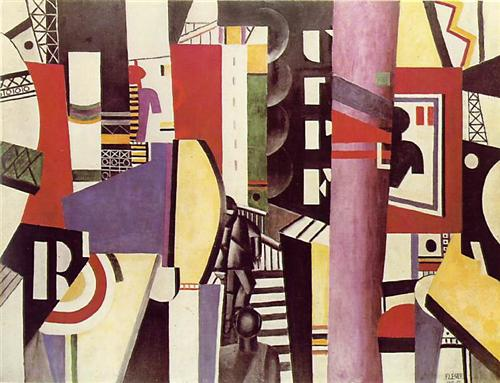Can you describe the mood or feeling that the image evokes? The mood conveyed by the image is one of dynamic intensity and vibrant energy. The sharp contrasts of colors and the intricate arrangement of geometric shapes create a sense of bustling activity and lively movement. This evokes feelings of excitement, curiosity, and a certain degree of tension. The abstract nature of the composition invites viewers to explore different emotional responses, possibly fluctuating between fascination and contemplation as they attempt to decode the myriad of forms and colors intertwined in the artwork. 